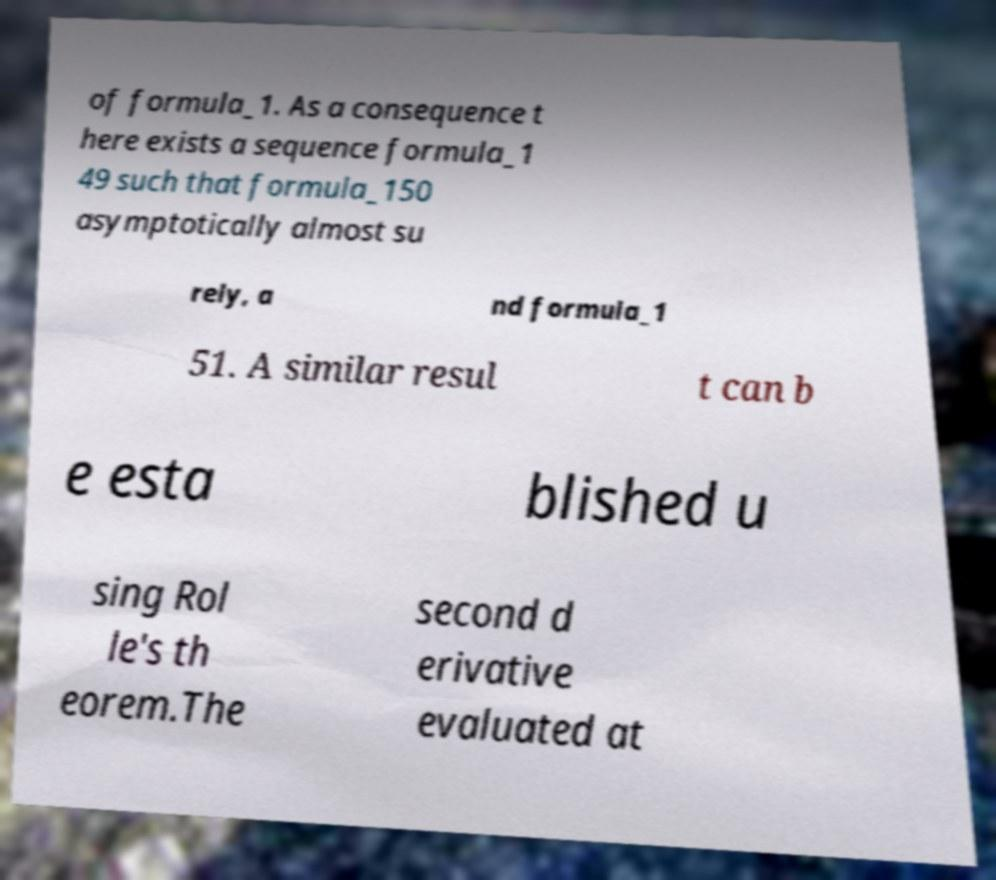For documentation purposes, I need the text within this image transcribed. Could you provide that? of formula_1. As a consequence t here exists a sequence formula_1 49 such that formula_150 asymptotically almost su rely, a nd formula_1 51. A similar resul t can b e esta blished u sing Rol le's th eorem.The second d erivative evaluated at 